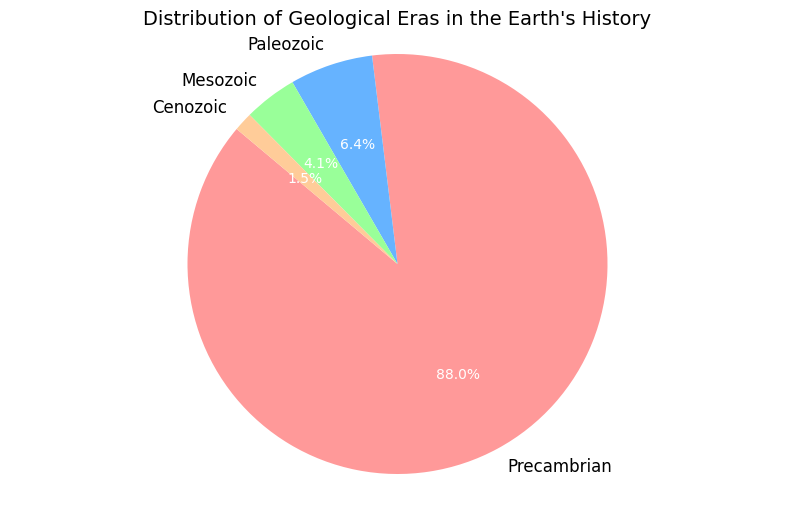What percentage of Earth's history does the Mesozoic Era cover? From the pie chart, we see that the Mesozoic Era covers a segment labeled with 4.12%.
Answer: 4.12% Which era has the shortest duration in terms of percentage? The pie chart shows that the Cenozoic Era has the smallest segment, labeled 1.46%.
Answer: Cenozoic How much longer is the Precambrian era compared to the Paleozoic era in terms of percentage? The Precambrian Era is shown to be 88.61%, while the Paleozoic Era is 6.45%. To find the difference, subtract 6.45 from 88.61: 88.61 - 6.45 = 82.16%.
Answer: 82.16% Which era has a duration that's nearly three times that of the Cenozoic Era? The pie chart shows the Cenozoic Era at 1.46%. Multiplying this by 3 gives 4.38. The Mesozoic Era, which is labeled 4.12%, is closest to 4.38%.
Answer: Mesozoic What is the combined percentage of the Paleozoic and Mesozoic eras? The pie chart indicates that the Paleozoic Era is 6.45% and the Mesozoic Era is 4.12%. Adding these together, we get 6.45% + 4.12% = 10.57%.
Answer: 10.57% What is the sum of the durations of the three most recent eras (Paleozoic, Mesozoic, and Cenozoic)? According to the pie chart, the Paleozoic Era is 6.45%, the Mesozoic Era is 4.12%, and the Cenozoic Era is 1.46%. Adding these percentages together gives 6.45% + 4.12% + 1.46% = 12.03%.
Answer: 12.03% Which era is represented by the largest segment in the pie chart? The largest segment on the pie chart is labeled with 88.61%, which corresponds to the Precambrian Era.
Answer: Precambrian What is the difference between the durations of the Mesozoic and Cenozoic eras? The pie chart indicates the Mesozoic Era at 4.12% and the Cenozoic Era at 1.46%. Subtracting these gives 4.12% - 1.46% = 2.66%.
Answer: 2.66% What's the average percentage of the durations of the Mesozoic and Paleozoic eras? The percentages for the Mesozoic and Paleozoic eras are 4.12% and 6.45%, respectively. The average is (4.12% + 6.45%) / 2 = 5.285%.
Answer: 5.285% Which era is depicted using the second largest segment? The pie chart's second largest segment is labeled 6.45%, which corresponds to the Paleozoic Era.
Answer: Paleozoic 